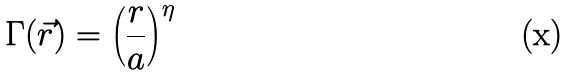Convert formula to latex. <formula><loc_0><loc_0><loc_500><loc_500>\Gamma ( \vec { r } ) = \left ( \frac { r } { a } \right ) ^ { \eta }</formula> 